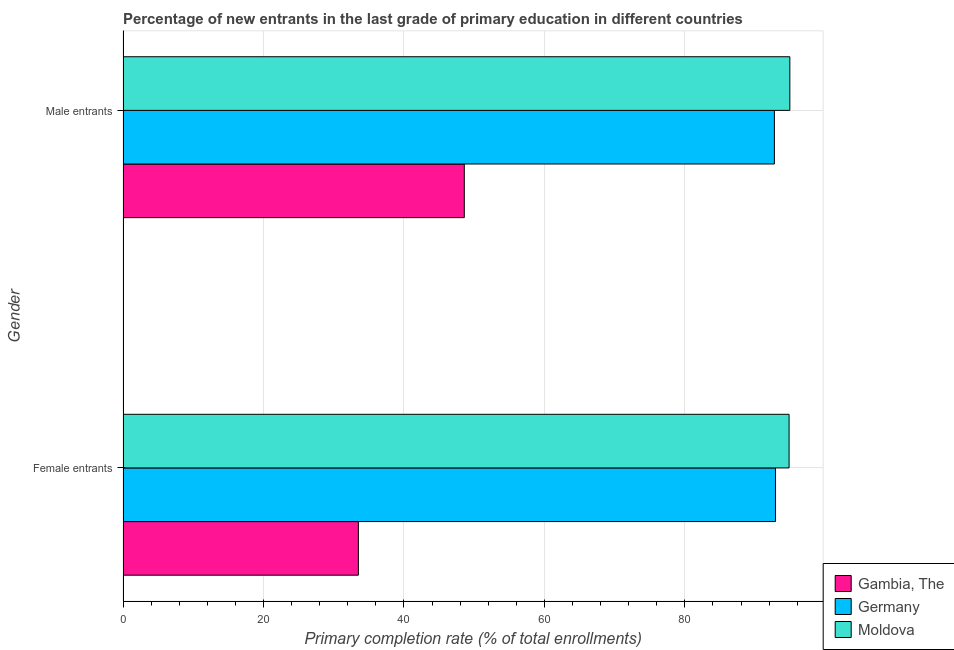How many different coloured bars are there?
Provide a succinct answer. 3. Are the number of bars per tick equal to the number of legend labels?
Your answer should be compact. Yes. Are the number of bars on each tick of the Y-axis equal?
Offer a terse response. Yes. What is the label of the 2nd group of bars from the top?
Your response must be concise. Female entrants. What is the primary completion rate of female entrants in Moldova?
Your answer should be compact. 94.84. Across all countries, what is the maximum primary completion rate of male entrants?
Offer a terse response. 94.95. Across all countries, what is the minimum primary completion rate of female entrants?
Your answer should be very brief. 33.51. In which country was the primary completion rate of female entrants maximum?
Offer a terse response. Moldova. In which country was the primary completion rate of male entrants minimum?
Your response must be concise. Gambia, The. What is the total primary completion rate of female entrants in the graph?
Make the answer very short. 221.25. What is the difference between the primary completion rate of male entrants in Gambia, The and that in Germany?
Offer a very short reply. -44.15. What is the difference between the primary completion rate of male entrants in Moldova and the primary completion rate of female entrants in Gambia, The?
Make the answer very short. 61.43. What is the average primary completion rate of female entrants per country?
Ensure brevity in your answer.  73.75. What is the difference between the primary completion rate of male entrants and primary completion rate of female entrants in Moldova?
Your answer should be compact. 0.11. What is the ratio of the primary completion rate of male entrants in Moldova to that in Germany?
Offer a very short reply. 1.02. Is the primary completion rate of female entrants in Germany less than that in Moldova?
Provide a short and direct response. Yes. What does the 2nd bar from the top in Female entrants represents?
Provide a short and direct response. Germany. What does the 1st bar from the bottom in Male entrants represents?
Your answer should be very brief. Gambia, The. How many countries are there in the graph?
Ensure brevity in your answer.  3. What is the difference between two consecutive major ticks on the X-axis?
Ensure brevity in your answer.  20. Are the values on the major ticks of X-axis written in scientific E-notation?
Your response must be concise. No. Does the graph contain grids?
Provide a short and direct response. Yes. Where does the legend appear in the graph?
Provide a succinct answer. Bottom right. What is the title of the graph?
Your answer should be very brief. Percentage of new entrants in the last grade of primary education in different countries. What is the label or title of the X-axis?
Give a very brief answer. Primary completion rate (% of total enrollments). What is the label or title of the Y-axis?
Your response must be concise. Gender. What is the Primary completion rate (% of total enrollments) in Gambia, The in Female entrants?
Ensure brevity in your answer.  33.51. What is the Primary completion rate (% of total enrollments) of Germany in Female entrants?
Provide a short and direct response. 92.9. What is the Primary completion rate (% of total enrollments) in Moldova in Female entrants?
Your answer should be compact. 94.84. What is the Primary completion rate (% of total enrollments) of Gambia, The in Male entrants?
Your answer should be compact. 48.6. What is the Primary completion rate (% of total enrollments) of Germany in Male entrants?
Offer a very short reply. 92.75. What is the Primary completion rate (% of total enrollments) of Moldova in Male entrants?
Your response must be concise. 94.95. Across all Gender, what is the maximum Primary completion rate (% of total enrollments) of Gambia, The?
Ensure brevity in your answer.  48.6. Across all Gender, what is the maximum Primary completion rate (% of total enrollments) in Germany?
Make the answer very short. 92.9. Across all Gender, what is the maximum Primary completion rate (% of total enrollments) in Moldova?
Give a very brief answer. 94.95. Across all Gender, what is the minimum Primary completion rate (% of total enrollments) of Gambia, The?
Make the answer very short. 33.51. Across all Gender, what is the minimum Primary completion rate (% of total enrollments) of Germany?
Provide a short and direct response. 92.75. Across all Gender, what is the minimum Primary completion rate (% of total enrollments) of Moldova?
Keep it short and to the point. 94.84. What is the total Primary completion rate (% of total enrollments) of Gambia, The in the graph?
Give a very brief answer. 82.11. What is the total Primary completion rate (% of total enrollments) in Germany in the graph?
Give a very brief answer. 185.65. What is the total Primary completion rate (% of total enrollments) in Moldova in the graph?
Your answer should be compact. 189.79. What is the difference between the Primary completion rate (% of total enrollments) of Gambia, The in Female entrants and that in Male entrants?
Your response must be concise. -15.08. What is the difference between the Primary completion rate (% of total enrollments) in Germany in Female entrants and that in Male entrants?
Your answer should be very brief. 0.15. What is the difference between the Primary completion rate (% of total enrollments) in Moldova in Female entrants and that in Male entrants?
Provide a short and direct response. -0.11. What is the difference between the Primary completion rate (% of total enrollments) in Gambia, The in Female entrants and the Primary completion rate (% of total enrollments) in Germany in Male entrants?
Offer a terse response. -59.24. What is the difference between the Primary completion rate (% of total enrollments) of Gambia, The in Female entrants and the Primary completion rate (% of total enrollments) of Moldova in Male entrants?
Your answer should be compact. -61.43. What is the difference between the Primary completion rate (% of total enrollments) of Germany in Female entrants and the Primary completion rate (% of total enrollments) of Moldova in Male entrants?
Offer a terse response. -2.05. What is the average Primary completion rate (% of total enrollments) of Gambia, The per Gender?
Provide a succinct answer. 41.05. What is the average Primary completion rate (% of total enrollments) of Germany per Gender?
Your answer should be very brief. 92.83. What is the average Primary completion rate (% of total enrollments) in Moldova per Gender?
Keep it short and to the point. 94.89. What is the difference between the Primary completion rate (% of total enrollments) of Gambia, The and Primary completion rate (% of total enrollments) of Germany in Female entrants?
Offer a very short reply. -59.39. What is the difference between the Primary completion rate (% of total enrollments) of Gambia, The and Primary completion rate (% of total enrollments) of Moldova in Female entrants?
Make the answer very short. -61.33. What is the difference between the Primary completion rate (% of total enrollments) of Germany and Primary completion rate (% of total enrollments) of Moldova in Female entrants?
Your answer should be compact. -1.94. What is the difference between the Primary completion rate (% of total enrollments) of Gambia, The and Primary completion rate (% of total enrollments) of Germany in Male entrants?
Offer a terse response. -44.15. What is the difference between the Primary completion rate (% of total enrollments) in Gambia, The and Primary completion rate (% of total enrollments) in Moldova in Male entrants?
Provide a succinct answer. -46.35. What is the difference between the Primary completion rate (% of total enrollments) of Germany and Primary completion rate (% of total enrollments) of Moldova in Male entrants?
Your answer should be very brief. -2.2. What is the ratio of the Primary completion rate (% of total enrollments) of Gambia, The in Female entrants to that in Male entrants?
Keep it short and to the point. 0.69. What is the difference between the highest and the second highest Primary completion rate (% of total enrollments) of Gambia, The?
Keep it short and to the point. 15.08. What is the difference between the highest and the second highest Primary completion rate (% of total enrollments) in Germany?
Your answer should be compact. 0.15. What is the difference between the highest and the second highest Primary completion rate (% of total enrollments) in Moldova?
Offer a terse response. 0.11. What is the difference between the highest and the lowest Primary completion rate (% of total enrollments) in Gambia, The?
Your answer should be very brief. 15.08. What is the difference between the highest and the lowest Primary completion rate (% of total enrollments) of Germany?
Your response must be concise. 0.15. What is the difference between the highest and the lowest Primary completion rate (% of total enrollments) in Moldova?
Offer a terse response. 0.11. 